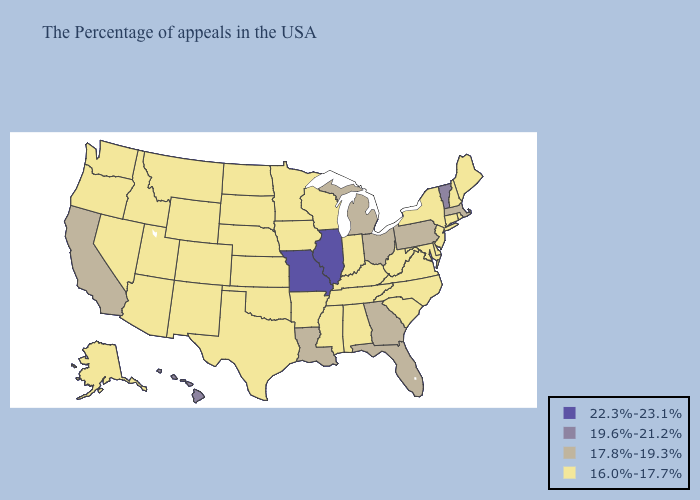What is the lowest value in the Northeast?
Give a very brief answer. 16.0%-17.7%. Does Indiana have a lower value than Michigan?
Short answer required. Yes. Name the states that have a value in the range 19.6%-21.2%?
Keep it brief. Vermont, Hawaii. Which states have the lowest value in the West?
Give a very brief answer. Wyoming, Colorado, New Mexico, Utah, Montana, Arizona, Idaho, Nevada, Washington, Oregon, Alaska. Among the states that border New Hampshire , does Vermont have the highest value?
Write a very short answer. Yes. Which states have the highest value in the USA?
Short answer required. Illinois, Missouri. Name the states that have a value in the range 22.3%-23.1%?
Be succinct. Illinois, Missouri. What is the value of Wyoming?
Write a very short answer. 16.0%-17.7%. How many symbols are there in the legend?
Short answer required. 4. What is the value of Iowa?
Be succinct. 16.0%-17.7%. Does the first symbol in the legend represent the smallest category?
Write a very short answer. No. What is the value of North Dakota?
Give a very brief answer. 16.0%-17.7%. Name the states that have a value in the range 22.3%-23.1%?
Give a very brief answer. Illinois, Missouri. What is the value of Maryland?
Quick response, please. 16.0%-17.7%. Name the states that have a value in the range 16.0%-17.7%?
Write a very short answer. Maine, Rhode Island, New Hampshire, Connecticut, New York, New Jersey, Delaware, Maryland, Virginia, North Carolina, South Carolina, West Virginia, Kentucky, Indiana, Alabama, Tennessee, Wisconsin, Mississippi, Arkansas, Minnesota, Iowa, Kansas, Nebraska, Oklahoma, Texas, South Dakota, North Dakota, Wyoming, Colorado, New Mexico, Utah, Montana, Arizona, Idaho, Nevada, Washington, Oregon, Alaska. 